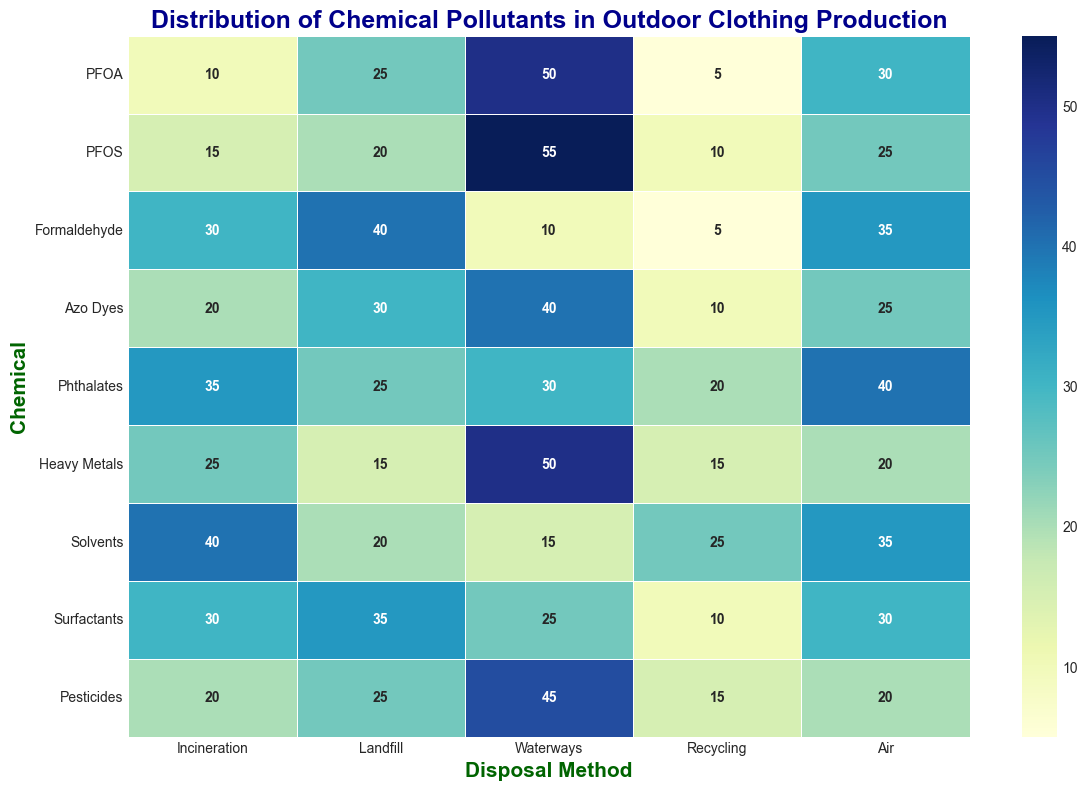What chemical is most frequently disposed of via waterways? To determine which chemical is most frequently disposed of via waterways, look at the row labeled 'Waterways' and identify the highest value. The highest value is 55, which corresponds to PFOS.
Answer: PFOS Which disposal method has the highest average release of pollutants? To find the disposal method with the highest average release, calculate the average for each disposal column. Add the values for each column and divide by the number of chemicals (9). The landfill column sums to 225, canals 340, recycling 115, air 275, and incineration 215. Dividing sums by 9, you get averages: landfill ≈ 25, canals ≈ 37.78, recycling ≈ 12.78, air ≈ 30.56, and incineration ≈ 23.89. Waterways have the highest average.
Answer: Waterways Is the release of Formaldehyde into air greater than into waterways? Compare the 'Air' and 'Waterways' values in the Formaldehyde row. Formaldehyde's 'Air' value is 35 and 'Waterways' is 10. Since 35 is greater than 10, the release into air is greater.
Answer: Yes Which chemical has the lowest release through recycling? Scan the 'Recycling' column for the lowest value. The lowest value in the 'Recycling' column is 5, which is seen for both PFOA and Formaldehyde.
Answer: PFOA and Formaldehyde Do Heavy Metals have higher releases into landfills or into air? Compare the 'Landfill' and 'Air' values in the Heavy Metals row. Heavy Metals' 'Landfill' value is 15 and 'Air' value is 20. Since 20 is greater than 15, the release into air is higher.
Answer: Air How many chemicals have their highest disposal method as Waterways? Look at each row and identify which disposal method has the highest value. Count how many times 'Waterways' is the highest. The chemicals are PFOA, PFOS, Azo Dyes, Heavy Metals, and Pesticides.
Answer: 5 What's the difference in the average release to air between Phthalates and Pesticides? Calculate the average release for 'Air' for both Phthalates (40) and Pesticides (20). The difference is 40 - 20.
Answer: 20 Which chemical results in the highest pollutant release via air and what is that amount? Scan the 'Air' column for the highest value. The highest value in the 'Air' column is 40, seen with Phthalates.
Answer: Phthalates, 40 